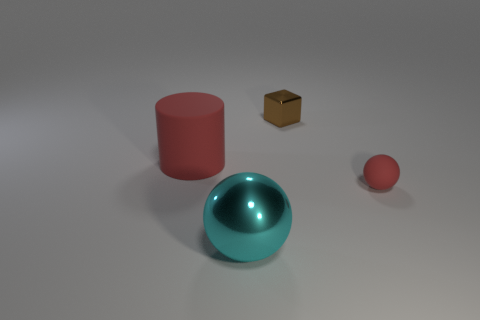Add 1 cyan objects. How many objects exist? 5 Subtract all cubes. How many objects are left? 3 Subtract 0 yellow cubes. How many objects are left? 4 Subtract all blocks. Subtract all spheres. How many objects are left? 1 Add 4 brown objects. How many brown objects are left? 5 Add 4 big cyan metal balls. How many big cyan metal balls exist? 5 